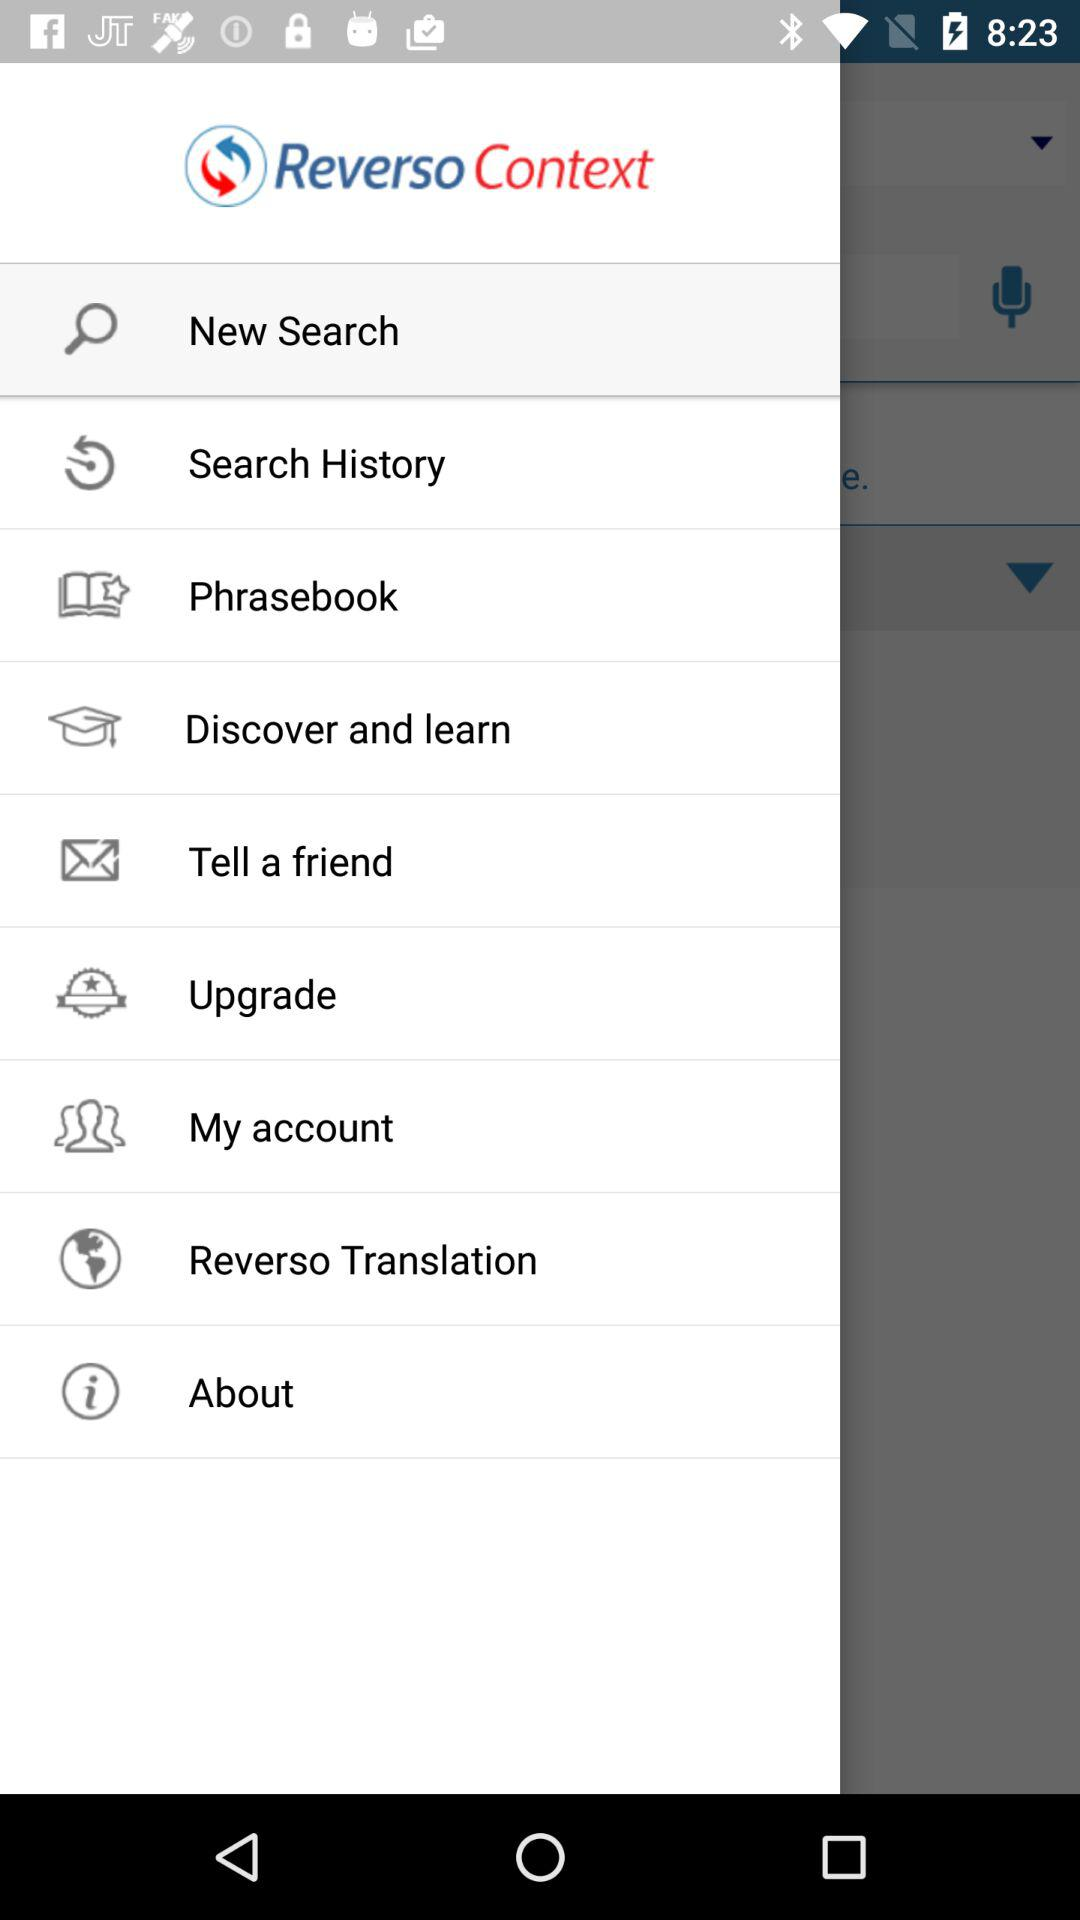What is the application name? The application name is "Reverso Context". 